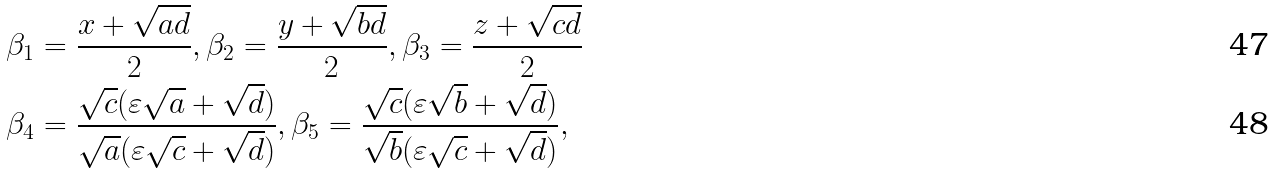<formula> <loc_0><loc_0><loc_500><loc_500>& \beta _ { 1 } = \frac { x + \sqrt { a d } } { 2 } , \beta _ { 2 } = \frac { y + \sqrt { b d } } { 2 } , \beta _ { 3 } = \frac { z + \sqrt { c d } } { 2 } \\ & \beta _ { 4 } = \frac { \sqrt { c } ( \varepsilon \sqrt { a } + \sqrt { d } ) } { \sqrt { a } ( \varepsilon \sqrt { c } + \sqrt { d } ) } , \beta _ { 5 } = \frac { \sqrt { c } ( \varepsilon \sqrt { b } + \sqrt { d } ) } { \sqrt { b } ( \varepsilon \sqrt { c } + \sqrt { d } ) } ,</formula> 